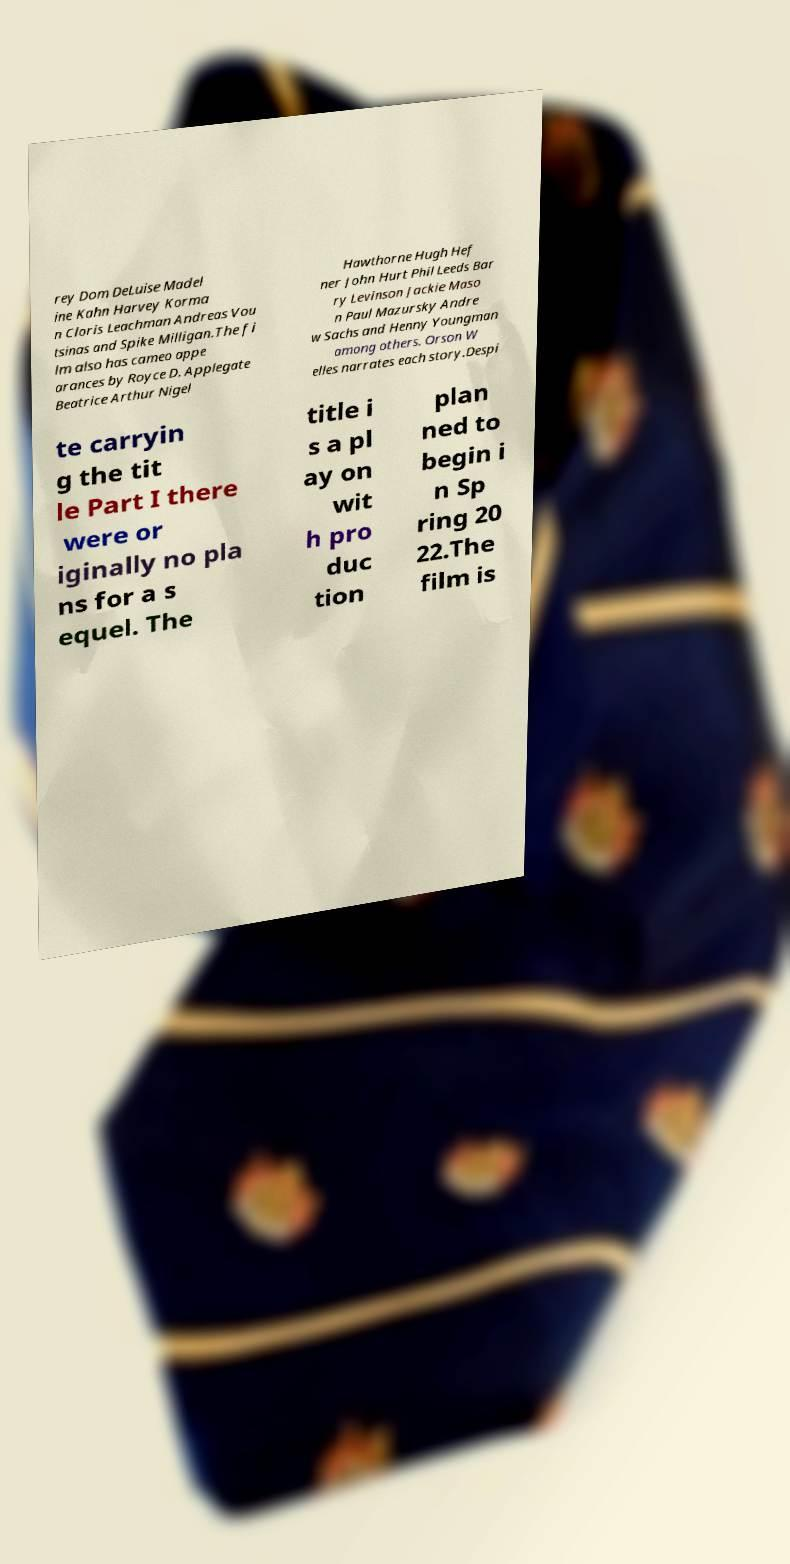For documentation purposes, I need the text within this image transcribed. Could you provide that? rey Dom DeLuise Madel ine Kahn Harvey Korma n Cloris Leachman Andreas Vou tsinas and Spike Milligan.The fi lm also has cameo appe arances by Royce D. Applegate Beatrice Arthur Nigel Hawthorne Hugh Hef ner John Hurt Phil Leeds Bar ry Levinson Jackie Maso n Paul Mazursky Andre w Sachs and Henny Youngman among others. Orson W elles narrates each story.Despi te carryin g the tit le Part I there were or iginally no pla ns for a s equel. The title i s a pl ay on wit h pro duc tion plan ned to begin i n Sp ring 20 22.The film is 